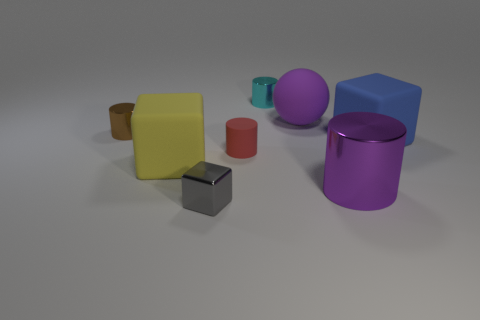How many other large objects have the same material as the gray thing?
Ensure brevity in your answer.  1. There is a red object; does it have the same size as the metal thing right of the cyan cylinder?
Your response must be concise. No. There is a object that is the same color as the sphere; what is its material?
Keep it short and to the point. Metal. There is a metallic object that is in front of the metallic cylinder that is in front of the small object on the left side of the small gray shiny thing; how big is it?
Keep it short and to the point. Small. Is the number of shiny objects on the left side of the large yellow rubber thing greater than the number of tiny blocks that are on the right side of the tiny matte object?
Provide a short and direct response. Yes. There is a small metal cylinder that is in front of the sphere; how many brown objects are behind it?
Offer a terse response. 0. Are there any shiny blocks that have the same color as the rubber ball?
Offer a terse response. No. Do the purple matte sphere and the purple metal cylinder have the same size?
Your answer should be compact. Yes. Is the big matte ball the same color as the small shiny cube?
Provide a short and direct response. No. There is a big thing behind the small shiny cylinder to the left of the cyan cylinder; what is its material?
Provide a succinct answer. Rubber. 